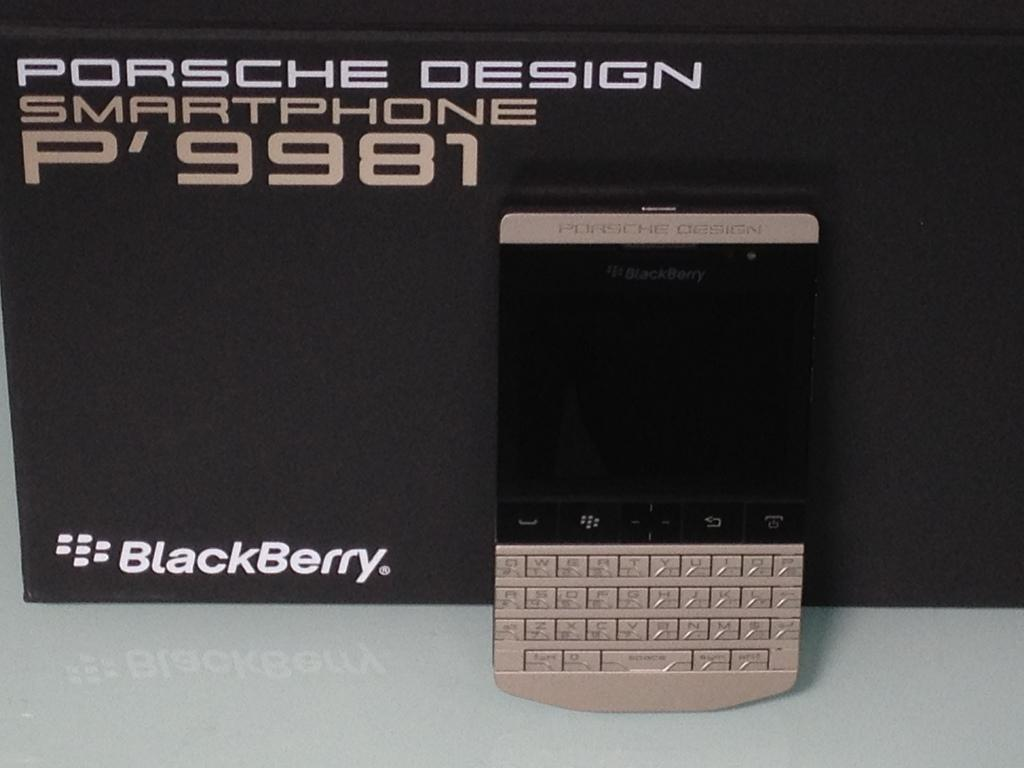Provide a one-sentence caption for the provided image. a smartphone with a p'9981 sign on the front. 